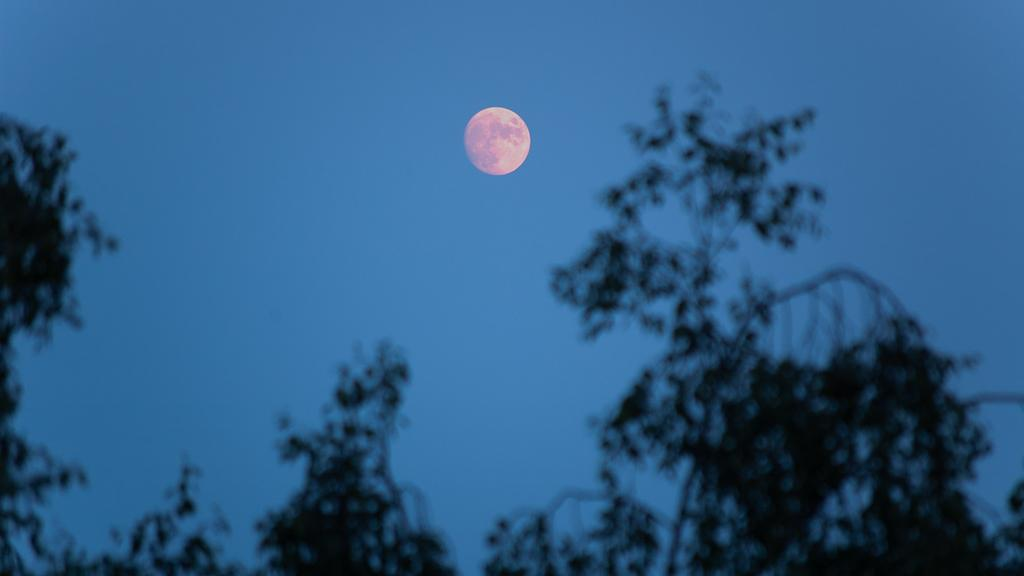What type of vegetation can be seen in the image? There are trees in the image. What celestial body is visible in the sky in the image? The moon is visible in the sky in the image. How does love affect the trees in the image? Love does not affect the trees in the image, as there is no indication of emotions or relationships in the image. 